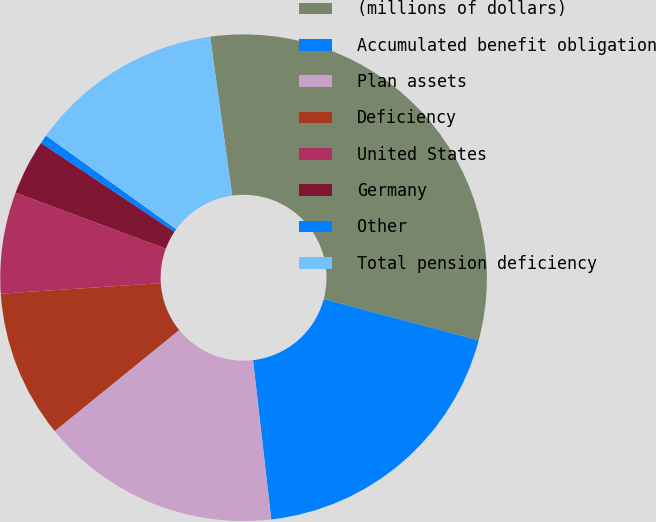Convert chart. <chart><loc_0><loc_0><loc_500><loc_500><pie_chart><fcel>(millions of dollars)<fcel>Accumulated benefit obligation<fcel>Plan assets<fcel>Deficiency<fcel>United States<fcel>Germany<fcel>Other<fcel>Total pension deficiency<nl><fcel>31.34%<fcel>19.04%<fcel>15.96%<fcel>9.81%<fcel>6.73%<fcel>3.66%<fcel>0.58%<fcel>12.88%<nl></chart> 